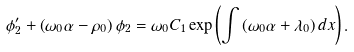Convert formula to latex. <formula><loc_0><loc_0><loc_500><loc_500>\phi _ { 2 } ^ { \prime } + \left ( \omega _ { 0 } \alpha - \rho _ { 0 } \right ) \phi _ { 2 } = \omega _ { 0 } C _ { 1 } \exp \left ( \int \left ( \omega _ { 0 } \alpha + \lambda _ { 0 } \right ) d x \right ) .</formula> 